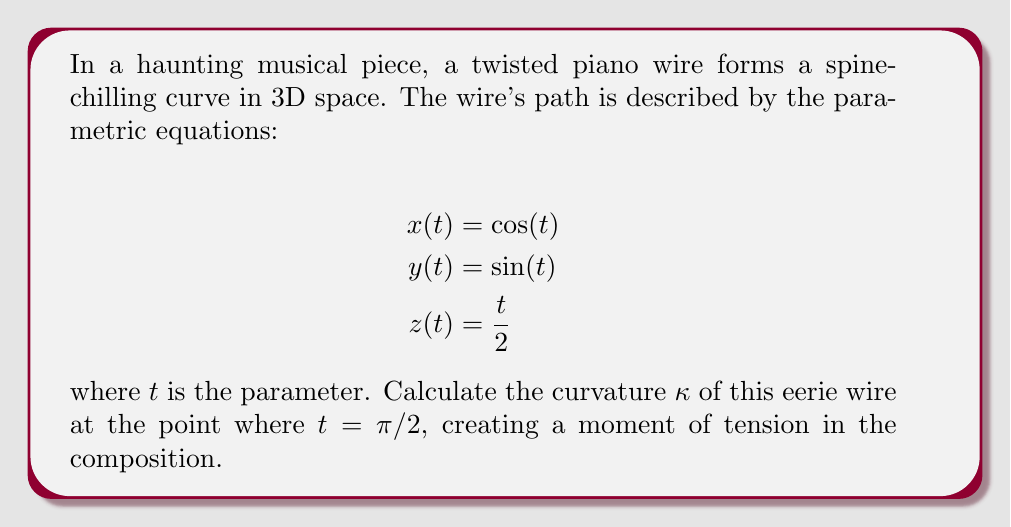Show me your answer to this math problem. To compute the curvature of the twisted piano wire, we'll follow these bone-chilling steps:

1) The curvature $\kappa$ is given by the formula:

   $$\kappa = \frac{|\mathbf{r}'(t) \times \mathbf{r}''(t)|}{|\mathbf{r}'(t)|^3}$$

   where $\mathbf{r}(t) = (x(t), y(t), z(t))$ is the position vector.

2) First, let's find $\mathbf{r}'(t)$ and $\mathbf{r}''(t)$:

   $$\mathbf{r}'(t) = (-\sin(t), \cos(t), \frac{1}{2})$$
   $$\mathbf{r}''(t) = (-\cos(t), -\sin(t), 0)$$

3) Now, we calculate the cross product $\mathbf{r}'(t) \times \mathbf{r}''(t)$:

   $$\mathbf{r}'(t) \times \mathbf{r}''(t) = \begin{vmatrix} 
   \mathbf{i} & \mathbf{j} & \mathbf{k} \\
   -\sin(t) & \cos(t) & \frac{1}{2} \\
   -\cos(t) & -\sin(t) & 0
   \end{vmatrix}$$

   $$= (\frac{1}{2}\sin(t), \frac{1}{2}\cos(t), \cos^2(t) + \sin^2(t)) = (\frac{1}{2}\sin(t), \frac{1}{2}\cos(t), 1)$$

4) The magnitude of this cross product is:

   $$|\mathbf{r}'(t) \times \mathbf{r}''(t)| = \sqrt{(\frac{1}{2}\sin(t))^2 + (\frac{1}{2}\cos(t))^2 + 1^2} = \sqrt{\frac{1}{4} + 1} = \frac{\sqrt{5}}{2}$$

5) Next, we calculate $|\mathbf{r}'(t)|$:

   $$|\mathbf{r}'(t)| = \sqrt{(-\sin(t))^2 + (\cos(t))^2 + (\frac{1}{2})^2} = \sqrt{1 + \frac{1}{4}} = \frac{\sqrt{5}}{2}$$

6) Now we can substitute these values into the curvature formula:

   $$\kappa = \frac{|\mathbf{r}'(t) \times \mathbf{r}''(t)|}{|\mathbf{r}'(t)|^3} = \frac{\frac{\sqrt{5}}{2}}{(\frac{\sqrt{5}}{2})^3} = \frac{2\sqrt{5}}{5\sqrt{5}} = \frac{2}{5}$$

7) This result is independent of $t$, so it holds for $t = \pi/2$ as well.

Thus, the curvature of the twisted piano wire is constant throughout its haunting path.
Answer: The curvature of the twisted piano wire at $t = \pi/2$ is $\kappa = \frac{2}{5}$. 